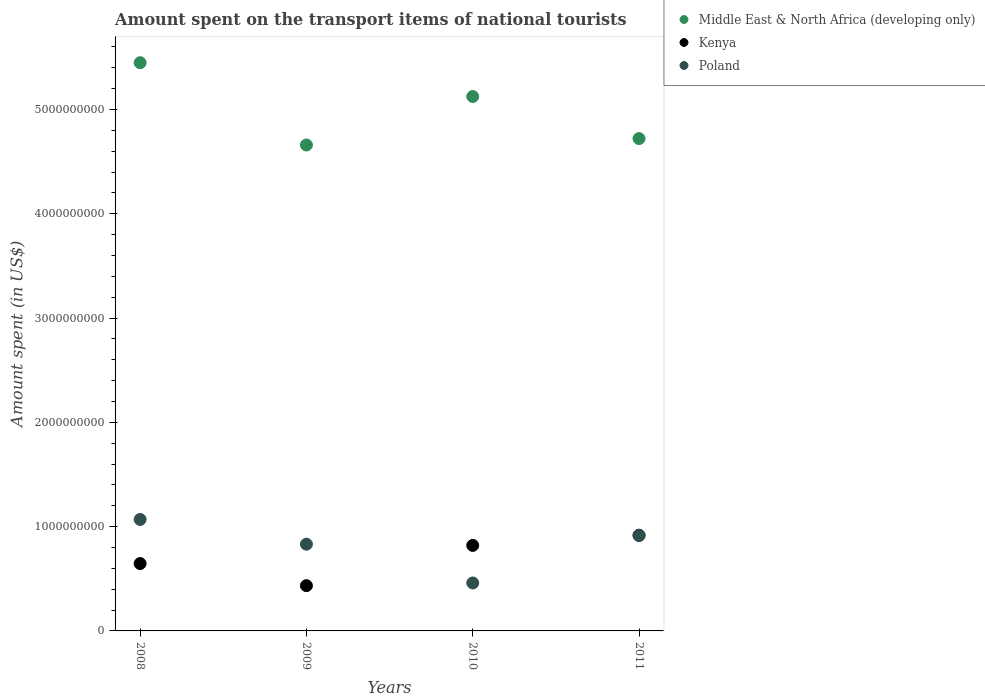Is the number of dotlines equal to the number of legend labels?
Make the answer very short. Yes. What is the amount spent on the transport items of national tourists in Poland in 2008?
Give a very brief answer. 1.07e+09. Across all years, what is the maximum amount spent on the transport items of national tourists in Poland?
Offer a terse response. 1.07e+09. Across all years, what is the minimum amount spent on the transport items of national tourists in Middle East & North Africa (developing only)?
Provide a short and direct response. 4.66e+09. What is the total amount spent on the transport items of national tourists in Kenya in the graph?
Make the answer very short. 2.82e+09. What is the difference between the amount spent on the transport items of national tourists in Kenya in 2008 and that in 2010?
Your response must be concise. -1.74e+08. What is the difference between the amount spent on the transport items of national tourists in Middle East & North Africa (developing only) in 2011 and the amount spent on the transport items of national tourists in Kenya in 2010?
Offer a very short reply. 3.90e+09. What is the average amount spent on the transport items of national tourists in Middle East & North Africa (developing only) per year?
Provide a short and direct response. 4.99e+09. In the year 2010, what is the difference between the amount spent on the transport items of national tourists in Kenya and amount spent on the transport items of national tourists in Middle East & North Africa (developing only)?
Keep it short and to the point. -4.30e+09. In how many years, is the amount spent on the transport items of national tourists in Middle East & North Africa (developing only) greater than 1200000000 US$?
Provide a short and direct response. 4. What is the ratio of the amount spent on the transport items of national tourists in Kenya in 2008 to that in 2011?
Provide a short and direct response. 0.7. Is the amount spent on the transport items of national tourists in Poland in 2008 less than that in 2010?
Make the answer very short. No. What is the difference between the highest and the second highest amount spent on the transport items of national tourists in Middle East & North Africa (developing only)?
Your answer should be compact. 3.24e+08. What is the difference between the highest and the lowest amount spent on the transport items of national tourists in Middle East & North Africa (developing only)?
Provide a succinct answer. 7.89e+08. In how many years, is the amount spent on the transport items of national tourists in Middle East & North Africa (developing only) greater than the average amount spent on the transport items of national tourists in Middle East & North Africa (developing only) taken over all years?
Your answer should be very brief. 2. Is the sum of the amount spent on the transport items of national tourists in Kenya in 2010 and 2011 greater than the maximum amount spent on the transport items of national tourists in Middle East & North Africa (developing only) across all years?
Your answer should be compact. No. Is it the case that in every year, the sum of the amount spent on the transport items of national tourists in Kenya and amount spent on the transport items of national tourists in Poland  is greater than the amount spent on the transport items of national tourists in Middle East & North Africa (developing only)?
Your response must be concise. No. Does the amount spent on the transport items of national tourists in Middle East & North Africa (developing only) monotonically increase over the years?
Give a very brief answer. No. Is the amount spent on the transport items of national tourists in Middle East & North Africa (developing only) strictly greater than the amount spent on the transport items of national tourists in Kenya over the years?
Give a very brief answer. Yes. How many years are there in the graph?
Provide a succinct answer. 4. What is the difference between two consecutive major ticks on the Y-axis?
Offer a very short reply. 1.00e+09. Are the values on the major ticks of Y-axis written in scientific E-notation?
Your answer should be compact. No. Does the graph contain any zero values?
Provide a succinct answer. No. Where does the legend appear in the graph?
Your answer should be compact. Top right. How many legend labels are there?
Make the answer very short. 3. How are the legend labels stacked?
Offer a very short reply. Vertical. What is the title of the graph?
Offer a terse response. Amount spent on the transport items of national tourists. What is the label or title of the Y-axis?
Give a very brief answer. Amount spent (in US$). What is the Amount spent (in US$) of Middle East & North Africa (developing only) in 2008?
Your answer should be compact. 5.45e+09. What is the Amount spent (in US$) in Kenya in 2008?
Offer a terse response. 6.46e+08. What is the Amount spent (in US$) in Poland in 2008?
Ensure brevity in your answer.  1.07e+09. What is the Amount spent (in US$) of Middle East & North Africa (developing only) in 2009?
Your answer should be compact. 4.66e+09. What is the Amount spent (in US$) in Kenya in 2009?
Your answer should be very brief. 4.34e+08. What is the Amount spent (in US$) in Poland in 2009?
Offer a terse response. 8.32e+08. What is the Amount spent (in US$) in Middle East & North Africa (developing only) in 2010?
Your response must be concise. 5.12e+09. What is the Amount spent (in US$) of Kenya in 2010?
Ensure brevity in your answer.  8.20e+08. What is the Amount spent (in US$) of Poland in 2010?
Provide a succinct answer. 4.60e+08. What is the Amount spent (in US$) of Middle East & North Africa (developing only) in 2011?
Ensure brevity in your answer.  4.72e+09. What is the Amount spent (in US$) of Kenya in 2011?
Your response must be concise. 9.18e+08. What is the Amount spent (in US$) of Poland in 2011?
Offer a very short reply. 9.15e+08. Across all years, what is the maximum Amount spent (in US$) in Middle East & North Africa (developing only)?
Your answer should be compact. 5.45e+09. Across all years, what is the maximum Amount spent (in US$) of Kenya?
Provide a succinct answer. 9.18e+08. Across all years, what is the maximum Amount spent (in US$) in Poland?
Make the answer very short. 1.07e+09. Across all years, what is the minimum Amount spent (in US$) in Middle East & North Africa (developing only)?
Your response must be concise. 4.66e+09. Across all years, what is the minimum Amount spent (in US$) of Kenya?
Provide a succinct answer. 4.34e+08. Across all years, what is the minimum Amount spent (in US$) of Poland?
Ensure brevity in your answer.  4.60e+08. What is the total Amount spent (in US$) of Middle East & North Africa (developing only) in the graph?
Provide a succinct answer. 2.00e+1. What is the total Amount spent (in US$) of Kenya in the graph?
Your response must be concise. 2.82e+09. What is the total Amount spent (in US$) of Poland in the graph?
Ensure brevity in your answer.  3.28e+09. What is the difference between the Amount spent (in US$) in Middle East & North Africa (developing only) in 2008 and that in 2009?
Make the answer very short. 7.89e+08. What is the difference between the Amount spent (in US$) in Kenya in 2008 and that in 2009?
Offer a terse response. 2.12e+08. What is the difference between the Amount spent (in US$) of Poland in 2008 and that in 2009?
Your answer should be compact. 2.37e+08. What is the difference between the Amount spent (in US$) of Middle East & North Africa (developing only) in 2008 and that in 2010?
Offer a very short reply. 3.24e+08. What is the difference between the Amount spent (in US$) in Kenya in 2008 and that in 2010?
Offer a terse response. -1.74e+08. What is the difference between the Amount spent (in US$) of Poland in 2008 and that in 2010?
Your answer should be very brief. 6.09e+08. What is the difference between the Amount spent (in US$) in Middle East & North Africa (developing only) in 2008 and that in 2011?
Give a very brief answer. 7.27e+08. What is the difference between the Amount spent (in US$) of Kenya in 2008 and that in 2011?
Your answer should be compact. -2.72e+08. What is the difference between the Amount spent (in US$) of Poland in 2008 and that in 2011?
Your response must be concise. 1.54e+08. What is the difference between the Amount spent (in US$) of Middle East & North Africa (developing only) in 2009 and that in 2010?
Offer a terse response. -4.65e+08. What is the difference between the Amount spent (in US$) of Kenya in 2009 and that in 2010?
Provide a succinct answer. -3.86e+08. What is the difference between the Amount spent (in US$) of Poland in 2009 and that in 2010?
Your answer should be very brief. 3.72e+08. What is the difference between the Amount spent (in US$) of Middle East & North Africa (developing only) in 2009 and that in 2011?
Offer a terse response. -6.17e+07. What is the difference between the Amount spent (in US$) of Kenya in 2009 and that in 2011?
Provide a short and direct response. -4.84e+08. What is the difference between the Amount spent (in US$) in Poland in 2009 and that in 2011?
Ensure brevity in your answer.  -8.30e+07. What is the difference between the Amount spent (in US$) in Middle East & North Africa (developing only) in 2010 and that in 2011?
Your response must be concise. 4.03e+08. What is the difference between the Amount spent (in US$) in Kenya in 2010 and that in 2011?
Provide a short and direct response. -9.80e+07. What is the difference between the Amount spent (in US$) of Poland in 2010 and that in 2011?
Offer a very short reply. -4.55e+08. What is the difference between the Amount spent (in US$) of Middle East & North Africa (developing only) in 2008 and the Amount spent (in US$) of Kenya in 2009?
Your answer should be compact. 5.01e+09. What is the difference between the Amount spent (in US$) in Middle East & North Africa (developing only) in 2008 and the Amount spent (in US$) in Poland in 2009?
Your response must be concise. 4.62e+09. What is the difference between the Amount spent (in US$) in Kenya in 2008 and the Amount spent (in US$) in Poland in 2009?
Your answer should be very brief. -1.86e+08. What is the difference between the Amount spent (in US$) of Middle East & North Africa (developing only) in 2008 and the Amount spent (in US$) of Kenya in 2010?
Your response must be concise. 4.63e+09. What is the difference between the Amount spent (in US$) of Middle East & North Africa (developing only) in 2008 and the Amount spent (in US$) of Poland in 2010?
Make the answer very short. 4.99e+09. What is the difference between the Amount spent (in US$) of Kenya in 2008 and the Amount spent (in US$) of Poland in 2010?
Your response must be concise. 1.86e+08. What is the difference between the Amount spent (in US$) in Middle East & North Africa (developing only) in 2008 and the Amount spent (in US$) in Kenya in 2011?
Provide a short and direct response. 4.53e+09. What is the difference between the Amount spent (in US$) of Middle East & North Africa (developing only) in 2008 and the Amount spent (in US$) of Poland in 2011?
Your answer should be compact. 4.53e+09. What is the difference between the Amount spent (in US$) of Kenya in 2008 and the Amount spent (in US$) of Poland in 2011?
Your answer should be compact. -2.69e+08. What is the difference between the Amount spent (in US$) in Middle East & North Africa (developing only) in 2009 and the Amount spent (in US$) in Kenya in 2010?
Offer a very short reply. 3.84e+09. What is the difference between the Amount spent (in US$) of Middle East & North Africa (developing only) in 2009 and the Amount spent (in US$) of Poland in 2010?
Offer a very short reply. 4.20e+09. What is the difference between the Amount spent (in US$) of Kenya in 2009 and the Amount spent (in US$) of Poland in 2010?
Keep it short and to the point. -2.60e+07. What is the difference between the Amount spent (in US$) of Middle East & North Africa (developing only) in 2009 and the Amount spent (in US$) of Kenya in 2011?
Provide a short and direct response. 3.74e+09. What is the difference between the Amount spent (in US$) of Middle East & North Africa (developing only) in 2009 and the Amount spent (in US$) of Poland in 2011?
Give a very brief answer. 3.74e+09. What is the difference between the Amount spent (in US$) in Kenya in 2009 and the Amount spent (in US$) in Poland in 2011?
Keep it short and to the point. -4.81e+08. What is the difference between the Amount spent (in US$) in Middle East & North Africa (developing only) in 2010 and the Amount spent (in US$) in Kenya in 2011?
Provide a short and direct response. 4.21e+09. What is the difference between the Amount spent (in US$) of Middle East & North Africa (developing only) in 2010 and the Amount spent (in US$) of Poland in 2011?
Offer a very short reply. 4.21e+09. What is the difference between the Amount spent (in US$) of Kenya in 2010 and the Amount spent (in US$) of Poland in 2011?
Offer a very short reply. -9.50e+07. What is the average Amount spent (in US$) of Middle East & North Africa (developing only) per year?
Make the answer very short. 4.99e+09. What is the average Amount spent (in US$) of Kenya per year?
Provide a short and direct response. 7.04e+08. What is the average Amount spent (in US$) of Poland per year?
Provide a short and direct response. 8.19e+08. In the year 2008, what is the difference between the Amount spent (in US$) in Middle East & North Africa (developing only) and Amount spent (in US$) in Kenya?
Ensure brevity in your answer.  4.80e+09. In the year 2008, what is the difference between the Amount spent (in US$) in Middle East & North Africa (developing only) and Amount spent (in US$) in Poland?
Make the answer very short. 4.38e+09. In the year 2008, what is the difference between the Amount spent (in US$) of Kenya and Amount spent (in US$) of Poland?
Your answer should be compact. -4.23e+08. In the year 2009, what is the difference between the Amount spent (in US$) in Middle East & North Africa (developing only) and Amount spent (in US$) in Kenya?
Keep it short and to the point. 4.23e+09. In the year 2009, what is the difference between the Amount spent (in US$) of Middle East & North Africa (developing only) and Amount spent (in US$) of Poland?
Provide a succinct answer. 3.83e+09. In the year 2009, what is the difference between the Amount spent (in US$) in Kenya and Amount spent (in US$) in Poland?
Keep it short and to the point. -3.98e+08. In the year 2010, what is the difference between the Amount spent (in US$) of Middle East & North Africa (developing only) and Amount spent (in US$) of Kenya?
Offer a terse response. 4.30e+09. In the year 2010, what is the difference between the Amount spent (in US$) in Middle East & North Africa (developing only) and Amount spent (in US$) in Poland?
Your answer should be very brief. 4.66e+09. In the year 2010, what is the difference between the Amount spent (in US$) of Kenya and Amount spent (in US$) of Poland?
Your response must be concise. 3.60e+08. In the year 2011, what is the difference between the Amount spent (in US$) of Middle East & North Africa (developing only) and Amount spent (in US$) of Kenya?
Your answer should be compact. 3.80e+09. In the year 2011, what is the difference between the Amount spent (in US$) of Middle East & North Africa (developing only) and Amount spent (in US$) of Poland?
Offer a terse response. 3.81e+09. In the year 2011, what is the difference between the Amount spent (in US$) of Kenya and Amount spent (in US$) of Poland?
Offer a very short reply. 3.00e+06. What is the ratio of the Amount spent (in US$) in Middle East & North Africa (developing only) in 2008 to that in 2009?
Ensure brevity in your answer.  1.17. What is the ratio of the Amount spent (in US$) in Kenya in 2008 to that in 2009?
Your response must be concise. 1.49. What is the ratio of the Amount spent (in US$) in Poland in 2008 to that in 2009?
Offer a terse response. 1.28. What is the ratio of the Amount spent (in US$) of Middle East & North Africa (developing only) in 2008 to that in 2010?
Ensure brevity in your answer.  1.06. What is the ratio of the Amount spent (in US$) in Kenya in 2008 to that in 2010?
Ensure brevity in your answer.  0.79. What is the ratio of the Amount spent (in US$) in Poland in 2008 to that in 2010?
Ensure brevity in your answer.  2.32. What is the ratio of the Amount spent (in US$) in Middle East & North Africa (developing only) in 2008 to that in 2011?
Ensure brevity in your answer.  1.15. What is the ratio of the Amount spent (in US$) in Kenya in 2008 to that in 2011?
Give a very brief answer. 0.7. What is the ratio of the Amount spent (in US$) of Poland in 2008 to that in 2011?
Make the answer very short. 1.17. What is the ratio of the Amount spent (in US$) in Middle East & North Africa (developing only) in 2009 to that in 2010?
Provide a succinct answer. 0.91. What is the ratio of the Amount spent (in US$) of Kenya in 2009 to that in 2010?
Offer a very short reply. 0.53. What is the ratio of the Amount spent (in US$) of Poland in 2009 to that in 2010?
Make the answer very short. 1.81. What is the ratio of the Amount spent (in US$) in Middle East & North Africa (developing only) in 2009 to that in 2011?
Your answer should be very brief. 0.99. What is the ratio of the Amount spent (in US$) in Kenya in 2009 to that in 2011?
Your answer should be compact. 0.47. What is the ratio of the Amount spent (in US$) of Poland in 2009 to that in 2011?
Ensure brevity in your answer.  0.91. What is the ratio of the Amount spent (in US$) in Middle East & North Africa (developing only) in 2010 to that in 2011?
Make the answer very short. 1.09. What is the ratio of the Amount spent (in US$) of Kenya in 2010 to that in 2011?
Your answer should be very brief. 0.89. What is the ratio of the Amount spent (in US$) in Poland in 2010 to that in 2011?
Make the answer very short. 0.5. What is the difference between the highest and the second highest Amount spent (in US$) of Middle East & North Africa (developing only)?
Provide a succinct answer. 3.24e+08. What is the difference between the highest and the second highest Amount spent (in US$) in Kenya?
Your answer should be compact. 9.80e+07. What is the difference between the highest and the second highest Amount spent (in US$) in Poland?
Make the answer very short. 1.54e+08. What is the difference between the highest and the lowest Amount spent (in US$) in Middle East & North Africa (developing only)?
Ensure brevity in your answer.  7.89e+08. What is the difference between the highest and the lowest Amount spent (in US$) of Kenya?
Give a very brief answer. 4.84e+08. What is the difference between the highest and the lowest Amount spent (in US$) in Poland?
Your response must be concise. 6.09e+08. 